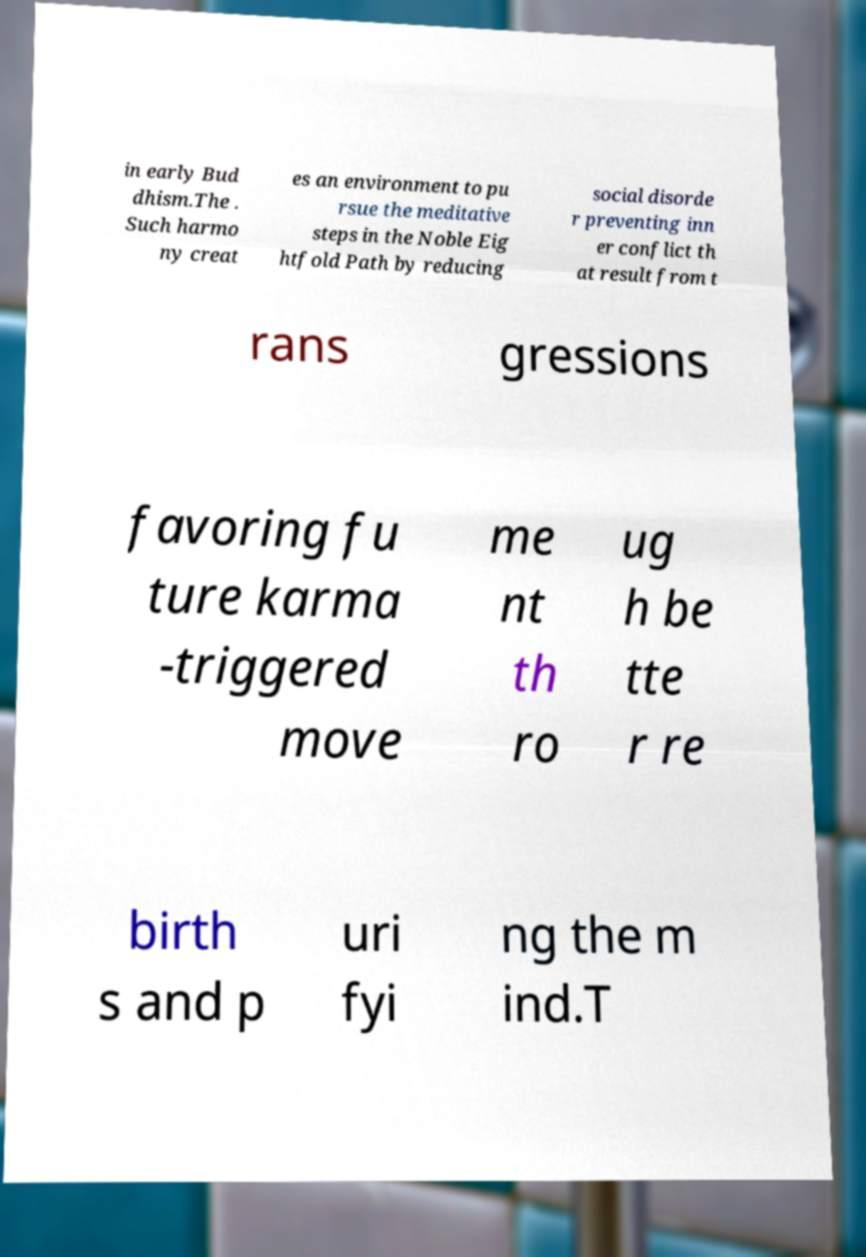Can you read and provide the text displayed in the image?This photo seems to have some interesting text. Can you extract and type it out for me? in early Bud dhism.The . Such harmo ny creat es an environment to pu rsue the meditative steps in the Noble Eig htfold Path by reducing social disorde r preventing inn er conflict th at result from t rans gressions favoring fu ture karma -triggered move me nt th ro ug h be tte r re birth s and p uri fyi ng the m ind.T 